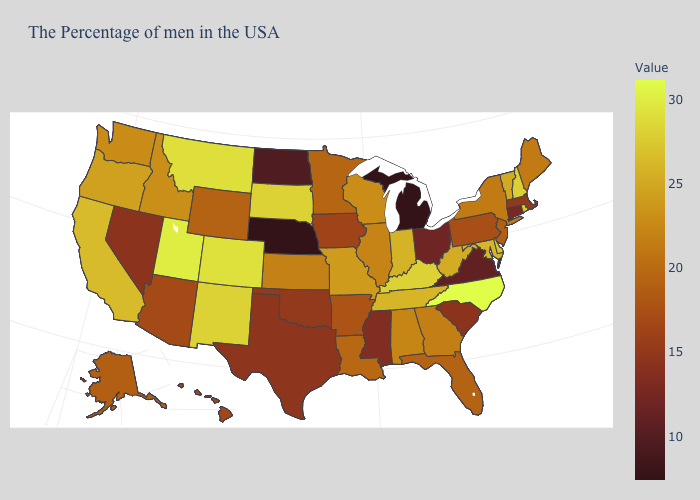Is the legend a continuous bar?
Write a very short answer. Yes. Which states hav the highest value in the MidWest?
Keep it brief. South Dakota. Does Nebraska have the lowest value in the USA?
Answer briefly. Yes. 